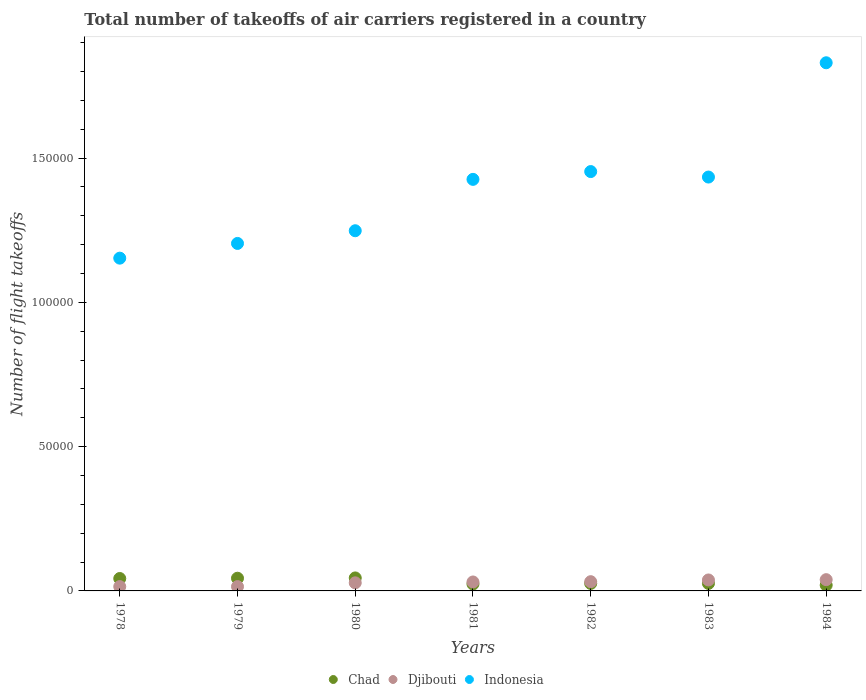How many different coloured dotlines are there?
Make the answer very short. 3. Is the number of dotlines equal to the number of legend labels?
Give a very brief answer. Yes. Across all years, what is the maximum total number of flight takeoffs in Indonesia?
Your response must be concise. 1.83e+05. Across all years, what is the minimum total number of flight takeoffs in Chad?
Your answer should be very brief. 2000. In which year was the total number of flight takeoffs in Djibouti minimum?
Make the answer very short. 1978. What is the total total number of flight takeoffs in Djibouti in the graph?
Ensure brevity in your answer.  1.98e+04. What is the difference between the total number of flight takeoffs in Indonesia in 1979 and that in 1980?
Your answer should be compact. -4400. What is the difference between the total number of flight takeoffs in Djibouti in 1983 and the total number of flight takeoffs in Chad in 1982?
Offer a terse response. 1200. What is the average total number of flight takeoffs in Chad per year?
Give a very brief answer. 3257.14. In the year 1978, what is the difference between the total number of flight takeoffs in Indonesia and total number of flight takeoffs in Chad?
Offer a terse response. 1.11e+05. What is the ratio of the total number of flight takeoffs in Indonesia in 1978 to that in 1980?
Keep it short and to the point. 0.92. Is the difference between the total number of flight takeoffs in Indonesia in 1978 and 1984 greater than the difference between the total number of flight takeoffs in Chad in 1978 and 1984?
Offer a terse response. No. What is the difference between the highest and the second highest total number of flight takeoffs in Indonesia?
Offer a terse response. 3.77e+04. What is the difference between the highest and the lowest total number of flight takeoffs in Djibouti?
Your answer should be compact. 2400. In how many years, is the total number of flight takeoffs in Djibouti greater than the average total number of flight takeoffs in Djibouti taken over all years?
Ensure brevity in your answer.  4. Is it the case that in every year, the sum of the total number of flight takeoffs in Djibouti and total number of flight takeoffs in Chad  is greater than the total number of flight takeoffs in Indonesia?
Keep it short and to the point. No. Is the total number of flight takeoffs in Indonesia strictly less than the total number of flight takeoffs in Djibouti over the years?
Your answer should be compact. No. How many years are there in the graph?
Your response must be concise. 7. Are the values on the major ticks of Y-axis written in scientific E-notation?
Provide a short and direct response. No. What is the title of the graph?
Provide a short and direct response. Total number of takeoffs of air carriers registered in a country. What is the label or title of the X-axis?
Keep it short and to the point. Years. What is the label or title of the Y-axis?
Offer a very short reply. Number of flight takeoffs. What is the Number of flight takeoffs of Chad in 1978?
Your response must be concise. 4300. What is the Number of flight takeoffs in Djibouti in 1978?
Ensure brevity in your answer.  1500. What is the Number of flight takeoffs of Indonesia in 1978?
Offer a very short reply. 1.15e+05. What is the Number of flight takeoffs of Chad in 1979?
Provide a succinct answer. 4400. What is the Number of flight takeoffs of Djibouti in 1979?
Provide a short and direct response. 1500. What is the Number of flight takeoffs of Indonesia in 1979?
Your answer should be compact. 1.20e+05. What is the Number of flight takeoffs in Chad in 1980?
Ensure brevity in your answer.  4500. What is the Number of flight takeoffs in Djibouti in 1980?
Keep it short and to the point. 2800. What is the Number of flight takeoffs of Indonesia in 1980?
Provide a succinct answer. 1.25e+05. What is the Number of flight takeoffs of Chad in 1981?
Make the answer very short. 2400. What is the Number of flight takeoffs in Djibouti in 1981?
Offer a terse response. 3100. What is the Number of flight takeoffs of Indonesia in 1981?
Make the answer very short. 1.43e+05. What is the Number of flight takeoffs in Chad in 1982?
Provide a succinct answer. 2600. What is the Number of flight takeoffs of Djibouti in 1982?
Your response must be concise. 3200. What is the Number of flight takeoffs of Indonesia in 1982?
Make the answer very short. 1.45e+05. What is the Number of flight takeoffs in Chad in 1983?
Ensure brevity in your answer.  2600. What is the Number of flight takeoffs in Djibouti in 1983?
Provide a short and direct response. 3800. What is the Number of flight takeoffs of Indonesia in 1983?
Provide a succinct answer. 1.43e+05. What is the Number of flight takeoffs of Djibouti in 1984?
Your answer should be very brief. 3900. What is the Number of flight takeoffs in Indonesia in 1984?
Ensure brevity in your answer.  1.83e+05. Across all years, what is the maximum Number of flight takeoffs of Chad?
Ensure brevity in your answer.  4500. Across all years, what is the maximum Number of flight takeoffs of Djibouti?
Your answer should be very brief. 3900. Across all years, what is the maximum Number of flight takeoffs of Indonesia?
Your response must be concise. 1.83e+05. Across all years, what is the minimum Number of flight takeoffs in Djibouti?
Offer a very short reply. 1500. Across all years, what is the minimum Number of flight takeoffs in Indonesia?
Keep it short and to the point. 1.15e+05. What is the total Number of flight takeoffs in Chad in the graph?
Offer a very short reply. 2.28e+04. What is the total Number of flight takeoffs in Djibouti in the graph?
Keep it short and to the point. 1.98e+04. What is the total Number of flight takeoffs of Indonesia in the graph?
Offer a very short reply. 9.75e+05. What is the difference between the Number of flight takeoffs of Chad in 1978 and that in 1979?
Make the answer very short. -100. What is the difference between the Number of flight takeoffs of Indonesia in 1978 and that in 1979?
Offer a terse response. -5100. What is the difference between the Number of flight takeoffs of Chad in 1978 and that in 1980?
Your response must be concise. -200. What is the difference between the Number of flight takeoffs of Djibouti in 1978 and that in 1980?
Your answer should be compact. -1300. What is the difference between the Number of flight takeoffs of Indonesia in 1978 and that in 1980?
Provide a short and direct response. -9500. What is the difference between the Number of flight takeoffs of Chad in 1978 and that in 1981?
Your answer should be very brief. 1900. What is the difference between the Number of flight takeoffs of Djibouti in 1978 and that in 1981?
Your answer should be compact. -1600. What is the difference between the Number of flight takeoffs of Indonesia in 1978 and that in 1981?
Offer a very short reply. -2.73e+04. What is the difference between the Number of flight takeoffs of Chad in 1978 and that in 1982?
Make the answer very short. 1700. What is the difference between the Number of flight takeoffs of Djibouti in 1978 and that in 1982?
Offer a terse response. -1700. What is the difference between the Number of flight takeoffs in Indonesia in 1978 and that in 1982?
Your answer should be compact. -3.00e+04. What is the difference between the Number of flight takeoffs in Chad in 1978 and that in 1983?
Offer a terse response. 1700. What is the difference between the Number of flight takeoffs in Djibouti in 1978 and that in 1983?
Offer a terse response. -2300. What is the difference between the Number of flight takeoffs in Indonesia in 1978 and that in 1983?
Offer a very short reply. -2.81e+04. What is the difference between the Number of flight takeoffs in Chad in 1978 and that in 1984?
Your answer should be very brief. 2300. What is the difference between the Number of flight takeoffs of Djibouti in 1978 and that in 1984?
Keep it short and to the point. -2400. What is the difference between the Number of flight takeoffs in Indonesia in 1978 and that in 1984?
Provide a succinct answer. -6.77e+04. What is the difference between the Number of flight takeoffs in Chad in 1979 and that in 1980?
Keep it short and to the point. -100. What is the difference between the Number of flight takeoffs in Djibouti in 1979 and that in 1980?
Your answer should be very brief. -1300. What is the difference between the Number of flight takeoffs of Indonesia in 1979 and that in 1980?
Offer a very short reply. -4400. What is the difference between the Number of flight takeoffs of Chad in 1979 and that in 1981?
Make the answer very short. 2000. What is the difference between the Number of flight takeoffs in Djibouti in 1979 and that in 1981?
Ensure brevity in your answer.  -1600. What is the difference between the Number of flight takeoffs in Indonesia in 1979 and that in 1981?
Your response must be concise. -2.22e+04. What is the difference between the Number of flight takeoffs of Chad in 1979 and that in 1982?
Provide a short and direct response. 1800. What is the difference between the Number of flight takeoffs of Djibouti in 1979 and that in 1982?
Make the answer very short. -1700. What is the difference between the Number of flight takeoffs of Indonesia in 1979 and that in 1982?
Ensure brevity in your answer.  -2.49e+04. What is the difference between the Number of flight takeoffs of Chad in 1979 and that in 1983?
Give a very brief answer. 1800. What is the difference between the Number of flight takeoffs of Djibouti in 1979 and that in 1983?
Offer a very short reply. -2300. What is the difference between the Number of flight takeoffs in Indonesia in 1979 and that in 1983?
Offer a terse response. -2.30e+04. What is the difference between the Number of flight takeoffs in Chad in 1979 and that in 1984?
Provide a short and direct response. 2400. What is the difference between the Number of flight takeoffs in Djibouti in 1979 and that in 1984?
Your answer should be very brief. -2400. What is the difference between the Number of flight takeoffs of Indonesia in 1979 and that in 1984?
Your response must be concise. -6.26e+04. What is the difference between the Number of flight takeoffs in Chad in 1980 and that in 1981?
Ensure brevity in your answer.  2100. What is the difference between the Number of flight takeoffs in Djibouti in 1980 and that in 1981?
Make the answer very short. -300. What is the difference between the Number of flight takeoffs in Indonesia in 1980 and that in 1981?
Provide a succinct answer. -1.78e+04. What is the difference between the Number of flight takeoffs in Chad in 1980 and that in 1982?
Offer a very short reply. 1900. What is the difference between the Number of flight takeoffs of Djibouti in 1980 and that in 1982?
Your response must be concise. -400. What is the difference between the Number of flight takeoffs in Indonesia in 1980 and that in 1982?
Offer a very short reply. -2.05e+04. What is the difference between the Number of flight takeoffs of Chad in 1980 and that in 1983?
Offer a very short reply. 1900. What is the difference between the Number of flight takeoffs of Djibouti in 1980 and that in 1983?
Keep it short and to the point. -1000. What is the difference between the Number of flight takeoffs in Indonesia in 1980 and that in 1983?
Your response must be concise. -1.86e+04. What is the difference between the Number of flight takeoffs of Chad in 1980 and that in 1984?
Offer a terse response. 2500. What is the difference between the Number of flight takeoffs in Djibouti in 1980 and that in 1984?
Your answer should be compact. -1100. What is the difference between the Number of flight takeoffs of Indonesia in 1980 and that in 1984?
Your answer should be very brief. -5.82e+04. What is the difference between the Number of flight takeoffs in Chad in 1981 and that in 1982?
Offer a very short reply. -200. What is the difference between the Number of flight takeoffs of Djibouti in 1981 and that in 1982?
Provide a short and direct response. -100. What is the difference between the Number of flight takeoffs of Indonesia in 1981 and that in 1982?
Give a very brief answer. -2700. What is the difference between the Number of flight takeoffs of Chad in 1981 and that in 1983?
Make the answer very short. -200. What is the difference between the Number of flight takeoffs of Djibouti in 1981 and that in 1983?
Provide a short and direct response. -700. What is the difference between the Number of flight takeoffs of Indonesia in 1981 and that in 1983?
Your answer should be very brief. -800. What is the difference between the Number of flight takeoffs in Chad in 1981 and that in 1984?
Ensure brevity in your answer.  400. What is the difference between the Number of flight takeoffs in Djibouti in 1981 and that in 1984?
Ensure brevity in your answer.  -800. What is the difference between the Number of flight takeoffs in Indonesia in 1981 and that in 1984?
Your answer should be very brief. -4.04e+04. What is the difference between the Number of flight takeoffs in Djibouti in 1982 and that in 1983?
Offer a terse response. -600. What is the difference between the Number of flight takeoffs in Indonesia in 1982 and that in 1983?
Provide a succinct answer. 1900. What is the difference between the Number of flight takeoffs in Chad in 1982 and that in 1984?
Provide a short and direct response. 600. What is the difference between the Number of flight takeoffs in Djibouti in 1982 and that in 1984?
Your response must be concise. -700. What is the difference between the Number of flight takeoffs of Indonesia in 1982 and that in 1984?
Your response must be concise. -3.77e+04. What is the difference between the Number of flight takeoffs in Chad in 1983 and that in 1984?
Ensure brevity in your answer.  600. What is the difference between the Number of flight takeoffs of Djibouti in 1983 and that in 1984?
Provide a succinct answer. -100. What is the difference between the Number of flight takeoffs of Indonesia in 1983 and that in 1984?
Provide a succinct answer. -3.96e+04. What is the difference between the Number of flight takeoffs of Chad in 1978 and the Number of flight takeoffs of Djibouti in 1979?
Make the answer very short. 2800. What is the difference between the Number of flight takeoffs in Chad in 1978 and the Number of flight takeoffs in Indonesia in 1979?
Make the answer very short. -1.16e+05. What is the difference between the Number of flight takeoffs of Djibouti in 1978 and the Number of flight takeoffs of Indonesia in 1979?
Make the answer very short. -1.19e+05. What is the difference between the Number of flight takeoffs of Chad in 1978 and the Number of flight takeoffs of Djibouti in 1980?
Your response must be concise. 1500. What is the difference between the Number of flight takeoffs of Chad in 1978 and the Number of flight takeoffs of Indonesia in 1980?
Provide a short and direct response. -1.20e+05. What is the difference between the Number of flight takeoffs of Djibouti in 1978 and the Number of flight takeoffs of Indonesia in 1980?
Give a very brief answer. -1.23e+05. What is the difference between the Number of flight takeoffs in Chad in 1978 and the Number of flight takeoffs in Djibouti in 1981?
Offer a very short reply. 1200. What is the difference between the Number of flight takeoffs of Chad in 1978 and the Number of flight takeoffs of Indonesia in 1981?
Provide a short and direct response. -1.38e+05. What is the difference between the Number of flight takeoffs in Djibouti in 1978 and the Number of flight takeoffs in Indonesia in 1981?
Your answer should be very brief. -1.41e+05. What is the difference between the Number of flight takeoffs of Chad in 1978 and the Number of flight takeoffs of Djibouti in 1982?
Ensure brevity in your answer.  1100. What is the difference between the Number of flight takeoffs in Chad in 1978 and the Number of flight takeoffs in Indonesia in 1982?
Ensure brevity in your answer.  -1.41e+05. What is the difference between the Number of flight takeoffs in Djibouti in 1978 and the Number of flight takeoffs in Indonesia in 1982?
Your answer should be very brief. -1.44e+05. What is the difference between the Number of flight takeoffs in Chad in 1978 and the Number of flight takeoffs in Djibouti in 1983?
Your answer should be very brief. 500. What is the difference between the Number of flight takeoffs of Chad in 1978 and the Number of flight takeoffs of Indonesia in 1983?
Your response must be concise. -1.39e+05. What is the difference between the Number of flight takeoffs of Djibouti in 1978 and the Number of flight takeoffs of Indonesia in 1983?
Offer a very short reply. -1.42e+05. What is the difference between the Number of flight takeoffs of Chad in 1978 and the Number of flight takeoffs of Indonesia in 1984?
Give a very brief answer. -1.79e+05. What is the difference between the Number of flight takeoffs of Djibouti in 1978 and the Number of flight takeoffs of Indonesia in 1984?
Provide a succinct answer. -1.82e+05. What is the difference between the Number of flight takeoffs of Chad in 1979 and the Number of flight takeoffs of Djibouti in 1980?
Make the answer very short. 1600. What is the difference between the Number of flight takeoffs in Chad in 1979 and the Number of flight takeoffs in Indonesia in 1980?
Provide a short and direct response. -1.20e+05. What is the difference between the Number of flight takeoffs of Djibouti in 1979 and the Number of flight takeoffs of Indonesia in 1980?
Provide a succinct answer. -1.23e+05. What is the difference between the Number of flight takeoffs of Chad in 1979 and the Number of flight takeoffs of Djibouti in 1981?
Offer a terse response. 1300. What is the difference between the Number of flight takeoffs in Chad in 1979 and the Number of flight takeoffs in Indonesia in 1981?
Your answer should be very brief. -1.38e+05. What is the difference between the Number of flight takeoffs in Djibouti in 1979 and the Number of flight takeoffs in Indonesia in 1981?
Ensure brevity in your answer.  -1.41e+05. What is the difference between the Number of flight takeoffs of Chad in 1979 and the Number of flight takeoffs of Djibouti in 1982?
Keep it short and to the point. 1200. What is the difference between the Number of flight takeoffs in Chad in 1979 and the Number of flight takeoffs in Indonesia in 1982?
Your response must be concise. -1.41e+05. What is the difference between the Number of flight takeoffs in Djibouti in 1979 and the Number of flight takeoffs in Indonesia in 1982?
Make the answer very short. -1.44e+05. What is the difference between the Number of flight takeoffs in Chad in 1979 and the Number of flight takeoffs in Djibouti in 1983?
Provide a succinct answer. 600. What is the difference between the Number of flight takeoffs in Chad in 1979 and the Number of flight takeoffs in Indonesia in 1983?
Your response must be concise. -1.39e+05. What is the difference between the Number of flight takeoffs in Djibouti in 1979 and the Number of flight takeoffs in Indonesia in 1983?
Your answer should be compact. -1.42e+05. What is the difference between the Number of flight takeoffs of Chad in 1979 and the Number of flight takeoffs of Djibouti in 1984?
Offer a terse response. 500. What is the difference between the Number of flight takeoffs in Chad in 1979 and the Number of flight takeoffs in Indonesia in 1984?
Offer a terse response. -1.79e+05. What is the difference between the Number of flight takeoffs of Djibouti in 1979 and the Number of flight takeoffs of Indonesia in 1984?
Make the answer very short. -1.82e+05. What is the difference between the Number of flight takeoffs of Chad in 1980 and the Number of flight takeoffs of Djibouti in 1981?
Your response must be concise. 1400. What is the difference between the Number of flight takeoffs of Chad in 1980 and the Number of flight takeoffs of Indonesia in 1981?
Provide a succinct answer. -1.38e+05. What is the difference between the Number of flight takeoffs of Djibouti in 1980 and the Number of flight takeoffs of Indonesia in 1981?
Provide a succinct answer. -1.40e+05. What is the difference between the Number of flight takeoffs of Chad in 1980 and the Number of flight takeoffs of Djibouti in 1982?
Keep it short and to the point. 1300. What is the difference between the Number of flight takeoffs in Chad in 1980 and the Number of flight takeoffs in Indonesia in 1982?
Your response must be concise. -1.41e+05. What is the difference between the Number of flight takeoffs of Djibouti in 1980 and the Number of flight takeoffs of Indonesia in 1982?
Make the answer very short. -1.42e+05. What is the difference between the Number of flight takeoffs of Chad in 1980 and the Number of flight takeoffs of Djibouti in 1983?
Make the answer very short. 700. What is the difference between the Number of flight takeoffs of Chad in 1980 and the Number of flight takeoffs of Indonesia in 1983?
Give a very brief answer. -1.39e+05. What is the difference between the Number of flight takeoffs of Djibouti in 1980 and the Number of flight takeoffs of Indonesia in 1983?
Keep it short and to the point. -1.41e+05. What is the difference between the Number of flight takeoffs of Chad in 1980 and the Number of flight takeoffs of Djibouti in 1984?
Offer a terse response. 600. What is the difference between the Number of flight takeoffs of Chad in 1980 and the Number of flight takeoffs of Indonesia in 1984?
Offer a terse response. -1.78e+05. What is the difference between the Number of flight takeoffs of Djibouti in 1980 and the Number of flight takeoffs of Indonesia in 1984?
Offer a very short reply. -1.80e+05. What is the difference between the Number of flight takeoffs in Chad in 1981 and the Number of flight takeoffs in Djibouti in 1982?
Your response must be concise. -800. What is the difference between the Number of flight takeoffs in Chad in 1981 and the Number of flight takeoffs in Indonesia in 1982?
Your answer should be very brief. -1.43e+05. What is the difference between the Number of flight takeoffs of Djibouti in 1981 and the Number of flight takeoffs of Indonesia in 1982?
Keep it short and to the point. -1.42e+05. What is the difference between the Number of flight takeoffs in Chad in 1981 and the Number of flight takeoffs in Djibouti in 1983?
Your answer should be compact. -1400. What is the difference between the Number of flight takeoffs in Chad in 1981 and the Number of flight takeoffs in Indonesia in 1983?
Make the answer very short. -1.41e+05. What is the difference between the Number of flight takeoffs in Djibouti in 1981 and the Number of flight takeoffs in Indonesia in 1983?
Ensure brevity in your answer.  -1.40e+05. What is the difference between the Number of flight takeoffs of Chad in 1981 and the Number of flight takeoffs of Djibouti in 1984?
Provide a succinct answer. -1500. What is the difference between the Number of flight takeoffs in Chad in 1981 and the Number of flight takeoffs in Indonesia in 1984?
Offer a terse response. -1.81e+05. What is the difference between the Number of flight takeoffs of Djibouti in 1981 and the Number of flight takeoffs of Indonesia in 1984?
Make the answer very short. -1.80e+05. What is the difference between the Number of flight takeoffs in Chad in 1982 and the Number of flight takeoffs in Djibouti in 1983?
Your answer should be very brief. -1200. What is the difference between the Number of flight takeoffs of Chad in 1982 and the Number of flight takeoffs of Indonesia in 1983?
Your answer should be very brief. -1.41e+05. What is the difference between the Number of flight takeoffs in Djibouti in 1982 and the Number of flight takeoffs in Indonesia in 1983?
Give a very brief answer. -1.40e+05. What is the difference between the Number of flight takeoffs in Chad in 1982 and the Number of flight takeoffs in Djibouti in 1984?
Provide a short and direct response. -1300. What is the difference between the Number of flight takeoffs of Chad in 1982 and the Number of flight takeoffs of Indonesia in 1984?
Ensure brevity in your answer.  -1.80e+05. What is the difference between the Number of flight takeoffs in Djibouti in 1982 and the Number of flight takeoffs in Indonesia in 1984?
Keep it short and to the point. -1.80e+05. What is the difference between the Number of flight takeoffs of Chad in 1983 and the Number of flight takeoffs of Djibouti in 1984?
Keep it short and to the point. -1300. What is the difference between the Number of flight takeoffs in Chad in 1983 and the Number of flight takeoffs in Indonesia in 1984?
Give a very brief answer. -1.80e+05. What is the difference between the Number of flight takeoffs of Djibouti in 1983 and the Number of flight takeoffs of Indonesia in 1984?
Provide a succinct answer. -1.79e+05. What is the average Number of flight takeoffs in Chad per year?
Your response must be concise. 3257.14. What is the average Number of flight takeoffs in Djibouti per year?
Your response must be concise. 2828.57. What is the average Number of flight takeoffs in Indonesia per year?
Give a very brief answer. 1.39e+05. In the year 1978, what is the difference between the Number of flight takeoffs of Chad and Number of flight takeoffs of Djibouti?
Offer a very short reply. 2800. In the year 1978, what is the difference between the Number of flight takeoffs in Chad and Number of flight takeoffs in Indonesia?
Keep it short and to the point. -1.11e+05. In the year 1978, what is the difference between the Number of flight takeoffs in Djibouti and Number of flight takeoffs in Indonesia?
Your answer should be compact. -1.14e+05. In the year 1979, what is the difference between the Number of flight takeoffs of Chad and Number of flight takeoffs of Djibouti?
Provide a short and direct response. 2900. In the year 1979, what is the difference between the Number of flight takeoffs of Chad and Number of flight takeoffs of Indonesia?
Ensure brevity in your answer.  -1.16e+05. In the year 1979, what is the difference between the Number of flight takeoffs in Djibouti and Number of flight takeoffs in Indonesia?
Your answer should be very brief. -1.19e+05. In the year 1980, what is the difference between the Number of flight takeoffs of Chad and Number of flight takeoffs of Djibouti?
Offer a very short reply. 1700. In the year 1980, what is the difference between the Number of flight takeoffs in Chad and Number of flight takeoffs in Indonesia?
Provide a short and direct response. -1.20e+05. In the year 1980, what is the difference between the Number of flight takeoffs in Djibouti and Number of flight takeoffs in Indonesia?
Keep it short and to the point. -1.22e+05. In the year 1981, what is the difference between the Number of flight takeoffs of Chad and Number of flight takeoffs of Djibouti?
Keep it short and to the point. -700. In the year 1981, what is the difference between the Number of flight takeoffs of Chad and Number of flight takeoffs of Indonesia?
Your answer should be compact. -1.40e+05. In the year 1981, what is the difference between the Number of flight takeoffs in Djibouti and Number of flight takeoffs in Indonesia?
Provide a succinct answer. -1.40e+05. In the year 1982, what is the difference between the Number of flight takeoffs of Chad and Number of flight takeoffs of Djibouti?
Offer a terse response. -600. In the year 1982, what is the difference between the Number of flight takeoffs of Chad and Number of flight takeoffs of Indonesia?
Offer a terse response. -1.43e+05. In the year 1982, what is the difference between the Number of flight takeoffs in Djibouti and Number of flight takeoffs in Indonesia?
Ensure brevity in your answer.  -1.42e+05. In the year 1983, what is the difference between the Number of flight takeoffs of Chad and Number of flight takeoffs of Djibouti?
Your answer should be very brief. -1200. In the year 1983, what is the difference between the Number of flight takeoffs in Chad and Number of flight takeoffs in Indonesia?
Your response must be concise. -1.41e+05. In the year 1983, what is the difference between the Number of flight takeoffs of Djibouti and Number of flight takeoffs of Indonesia?
Offer a terse response. -1.40e+05. In the year 1984, what is the difference between the Number of flight takeoffs of Chad and Number of flight takeoffs of Djibouti?
Provide a succinct answer. -1900. In the year 1984, what is the difference between the Number of flight takeoffs in Chad and Number of flight takeoffs in Indonesia?
Your answer should be very brief. -1.81e+05. In the year 1984, what is the difference between the Number of flight takeoffs in Djibouti and Number of flight takeoffs in Indonesia?
Your response must be concise. -1.79e+05. What is the ratio of the Number of flight takeoffs of Chad in 1978 to that in 1979?
Your answer should be very brief. 0.98. What is the ratio of the Number of flight takeoffs in Djibouti in 1978 to that in 1979?
Offer a terse response. 1. What is the ratio of the Number of flight takeoffs of Indonesia in 1978 to that in 1979?
Keep it short and to the point. 0.96. What is the ratio of the Number of flight takeoffs of Chad in 1978 to that in 1980?
Your response must be concise. 0.96. What is the ratio of the Number of flight takeoffs in Djibouti in 1978 to that in 1980?
Offer a terse response. 0.54. What is the ratio of the Number of flight takeoffs in Indonesia in 1978 to that in 1980?
Ensure brevity in your answer.  0.92. What is the ratio of the Number of flight takeoffs in Chad in 1978 to that in 1981?
Provide a succinct answer. 1.79. What is the ratio of the Number of flight takeoffs in Djibouti in 1978 to that in 1981?
Make the answer very short. 0.48. What is the ratio of the Number of flight takeoffs of Indonesia in 1978 to that in 1981?
Provide a short and direct response. 0.81. What is the ratio of the Number of flight takeoffs in Chad in 1978 to that in 1982?
Provide a succinct answer. 1.65. What is the ratio of the Number of flight takeoffs of Djibouti in 1978 to that in 1982?
Make the answer very short. 0.47. What is the ratio of the Number of flight takeoffs of Indonesia in 1978 to that in 1982?
Give a very brief answer. 0.79. What is the ratio of the Number of flight takeoffs of Chad in 1978 to that in 1983?
Ensure brevity in your answer.  1.65. What is the ratio of the Number of flight takeoffs in Djibouti in 1978 to that in 1983?
Make the answer very short. 0.39. What is the ratio of the Number of flight takeoffs of Indonesia in 1978 to that in 1983?
Provide a succinct answer. 0.8. What is the ratio of the Number of flight takeoffs of Chad in 1978 to that in 1984?
Keep it short and to the point. 2.15. What is the ratio of the Number of flight takeoffs in Djibouti in 1978 to that in 1984?
Your response must be concise. 0.38. What is the ratio of the Number of flight takeoffs of Indonesia in 1978 to that in 1984?
Your answer should be very brief. 0.63. What is the ratio of the Number of flight takeoffs in Chad in 1979 to that in 1980?
Offer a terse response. 0.98. What is the ratio of the Number of flight takeoffs in Djibouti in 1979 to that in 1980?
Your answer should be compact. 0.54. What is the ratio of the Number of flight takeoffs in Indonesia in 1979 to that in 1980?
Your answer should be very brief. 0.96. What is the ratio of the Number of flight takeoffs of Chad in 1979 to that in 1981?
Your response must be concise. 1.83. What is the ratio of the Number of flight takeoffs in Djibouti in 1979 to that in 1981?
Make the answer very short. 0.48. What is the ratio of the Number of flight takeoffs of Indonesia in 1979 to that in 1981?
Ensure brevity in your answer.  0.84. What is the ratio of the Number of flight takeoffs in Chad in 1979 to that in 1982?
Your response must be concise. 1.69. What is the ratio of the Number of flight takeoffs of Djibouti in 1979 to that in 1982?
Keep it short and to the point. 0.47. What is the ratio of the Number of flight takeoffs in Indonesia in 1979 to that in 1982?
Give a very brief answer. 0.83. What is the ratio of the Number of flight takeoffs in Chad in 1979 to that in 1983?
Keep it short and to the point. 1.69. What is the ratio of the Number of flight takeoffs of Djibouti in 1979 to that in 1983?
Give a very brief answer. 0.39. What is the ratio of the Number of flight takeoffs in Indonesia in 1979 to that in 1983?
Offer a terse response. 0.84. What is the ratio of the Number of flight takeoffs of Chad in 1979 to that in 1984?
Your answer should be compact. 2.2. What is the ratio of the Number of flight takeoffs in Djibouti in 1979 to that in 1984?
Offer a very short reply. 0.38. What is the ratio of the Number of flight takeoffs of Indonesia in 1979 to that in 1984?
Keep it short and to the point. 0.66. What is the ratio of the Number of flight takeoffs in Chad in 1980 to that in 1981?
Your answer should be compact. 1.88. What is the ratio of the Number of flight takeoffs of Djibouti in 1980 to that in 1981?
Offer a terse response. 0.9. What is the ratio of the Number of flight takeoffs in Indonesia in 1980 to that in 1981?
Your answer should be very brief. 0.88. What is the ratio of the Number of flight takeoffs in Chad in 1980 to that in 1982?
Your answer should be compact. 1.73. What is the ratio of the Number of flight takeoffs in Djibouti in 1980 to that in 1982?
Provide a succinct answer. 0.88. What is the ratio of the Number of flight takeoffs of Indonesia in 1980 to that in 1982?
Provide a short and direct response. 0.86. What is the ratio of the Number of flight takeoffs of Chad in 1980 to that in 1983?
Give a very brief answer. 1.73. What is the ratio of the Number of flight takeoffs in Djibouti in 1980 to that in 1983?
Your answer should be compact. 0.74. What is the ratio of the Number of flight takeoffs of Indonesia in 1980 to that in 1983?
Provide a short and direct response. 0.87. What is the ratio of the Number of flight takeoffs in Chad in 1980 to that in 1984?
Your answer should be compact. 2.25. What is the ratio of the Number of flight takeoffs in Djibouti in 1980 to that in 1984?
Provide a short and direct response. 0.72. What is the ratio of the Number of flight takeoffs of Indonesia in 1980 to that in 1984?
Provide a short and direct response. 0.68. What is the ratio of the Number of flight takeoffs in Chad in 1981 to that in 1982?
Your answer should be very brief. 0.92. What is the ratio of the Number of flight takeoffs in Djibouti in 1981 to that in 1982?
Make the answer very short. 0.97. What is the ratio of the Number of flight takeoffs of Indonesia in 1981 to that in 1982?
Your answer should be compact. 0.98. What is the ratio of the Number of flight takeoffs of Djibouti in 1981 to that in 1983?
Provide a succinct answer. 0.82. What is the ratio of the Number of flight takeoffs in Indonesia in 1981 to that in 1983?
Your answer should be very brief. 0.99. What is the ratio of the Number of flight takeoffs in Chad in 1981 to that in 1984?
Offer a terse response. 1.2. What is the ratio of the Number of flight takeoffs in Djibouti in 1981 to that in 1984?
Offer a very short reply. 0.79. What is the ratio of the Number of flight takeoffs in Indonesia in 1981 to that in 1984?
Provide a short and direct response. 0.78. What is the ratio of the Number of flight takeoffs in Chad in 1982 to that in 1983?
Give a very brief answer. 1. What is the ratio of the Number of flight takeoffs in Djibouti in 1982 to that in 1983?
Provide a short and direct response. 0.84. What is the ratio of the Number of flight takeoffs in Indonesia in 1982 to that in 1983?
Offer a terse response. 1.01. What is the ratio of the Number of flight takeoffs of Djibouti in 1982 to that in 1984?
Keep it short and to the point. 0.82. What is the ratio of the Number of flight takeoffs in Indonesia in 1982 to that in 1984?
Your response must be concise. 0.79. What is the ratio of the Number of flight takeoffs in Djibouti in 1983 to that in 1984?
Keep it short and to the point. 0.97. What is the ratio of the Number of flight takeoffs of Indonesia in 1983 to that in 1984?
Provide a succinct answer. 0.78. What is the difference between the highest and the second highest Number of flight takeoffs in Chad?
Keep it short and to the point. 100. What is the difference between the highest and the second highest Number of flight takeoffs of Indonesia?
Provide a short and direct response. 3.77e+04. What is the difference between the highest and the lowest Number of flight takeoffs of Chad?
Offer a terse response. 2500. What is the difference between the highest and the lowest Number of flight takeoffs in Djibouti?
Ensure brevity in your answer.  2400. What is the difference between the highest and the lowest Number of flight takeoffs in Indonesia?
Offer a terse response. 6.77e+04. 